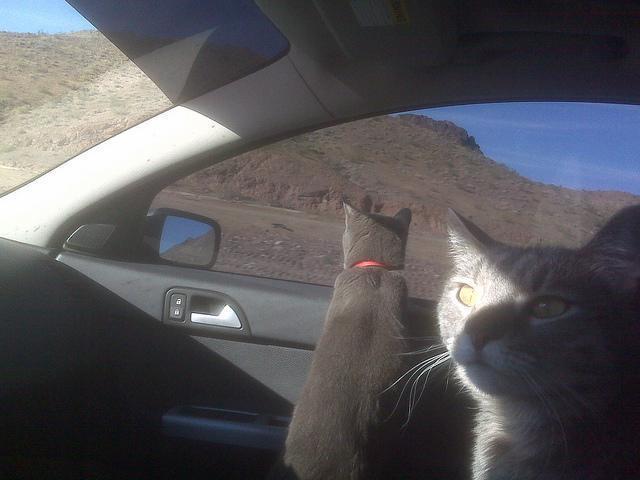Which section of the car is the cat by the window sitting at?
Indicate the correct response by choosing from the four available options to answer the question.
Options: Passenger backseat, front passenger, driver seat, driver backseat. Front passenger. 